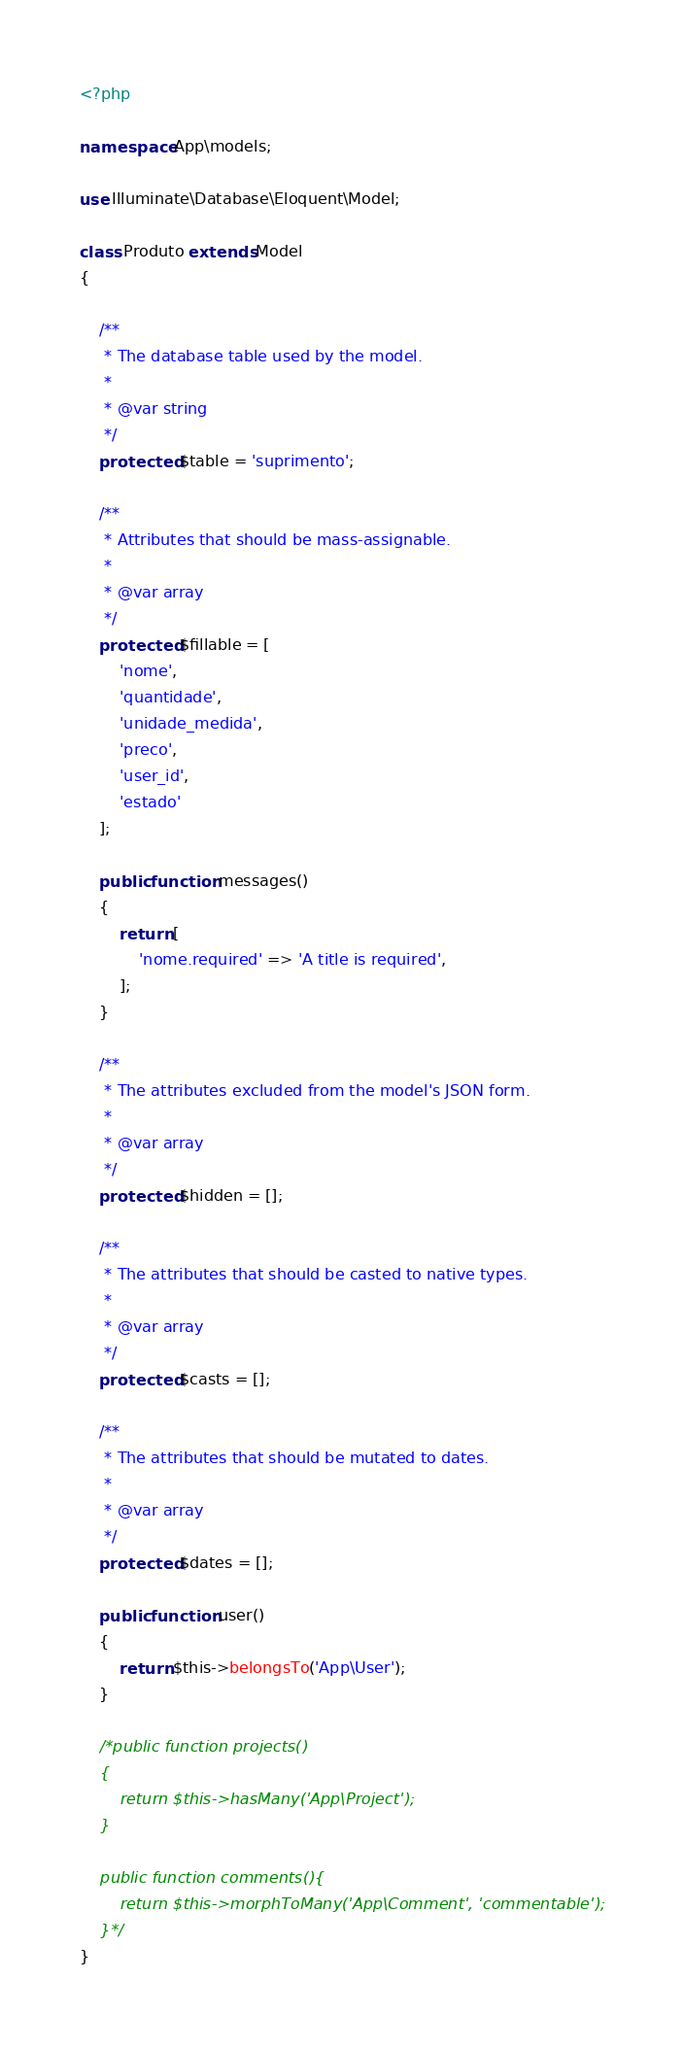<code> <loc_0><loc_0><loc_500><loc_500><_PHP_><?php

namespace App\models;

use Illuminate\Database\Eloquent\Model;

class Produto extends Model
{

    /**
     * The database table used by the model.
     *
     * @var string
     */
    protected $table = 'suprimento';

    /**
     * Attributes that should be mass-assignable.
     *
     * @var array
     */
    protected $fillable = [
        'nome',
        'quantidade',
        'unidade_medida',
        'preco',
        'user_id',
        'estado'
    ];

    public function messages()
    {
        return [
            'nome.required' => 'A title is required',
        ];
    }

    /**
     * The attributes excluded from the model's JSON form.
     *
     * @var array
     */
    protected $hidden = [];

    /**
     * The attributes that should be casted to native types.
     *
     * @var array
     */
    protected $casts = [];

    /**
     * The attributes that should be mutated to dates.
     *
     * @var array
     */
    protected $dates = [];

    public function user()
    {
        return $this->belongsTo('App\User');
    }

    /*public function projects()
    {
        return $this->hasMany('App\Project');
    }

    public function comments(){
        return $this->morphToMany('App\Comment', 'commentable');
    }*/
}
</code> 